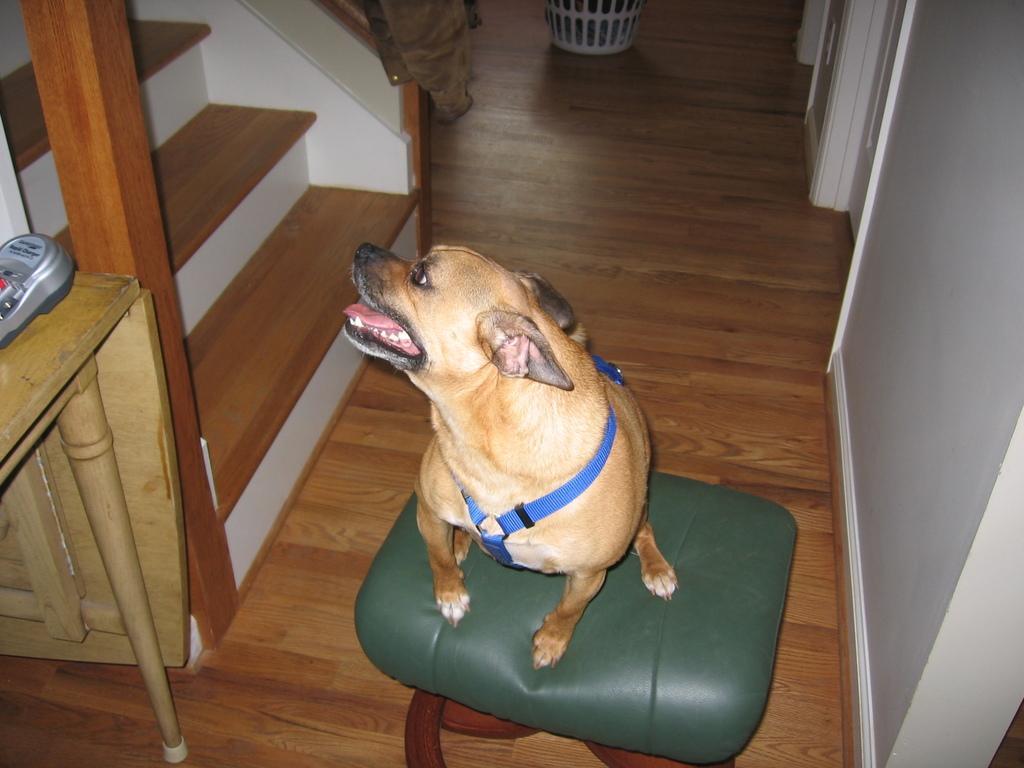Could you give a brief overview of what you see in this image? In this image we can see a stool on the wooden floor. On the tools, we can see a dog. On the right side of the image, we can see a wall and a door. On the left side of the image, we can see stairs, table, jacket, wooden pillar and one grey color object. There is a plastic object at the top of the image. 